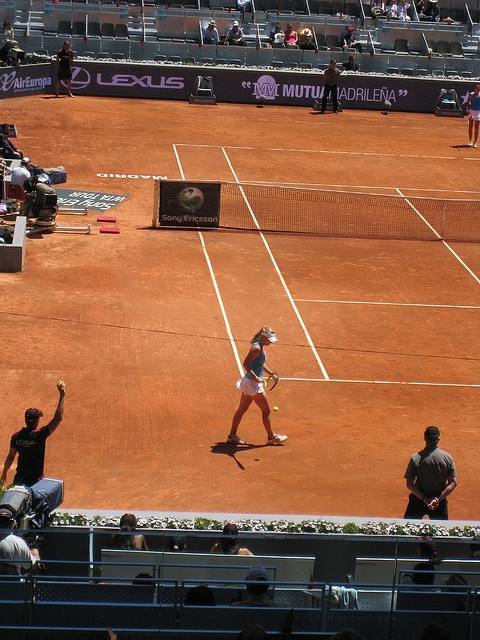Describe the objects in this image and their specific colors. I can see chair in gray, black, purple, and darkgray tones, people in gray, black, maroon, and darkgray tones, people in gray, black, salmon, maroon, and brown tones, bench in gray, black, navy, blue, and purple tones, and bench in gray, black, and darkblue tones in this image. 